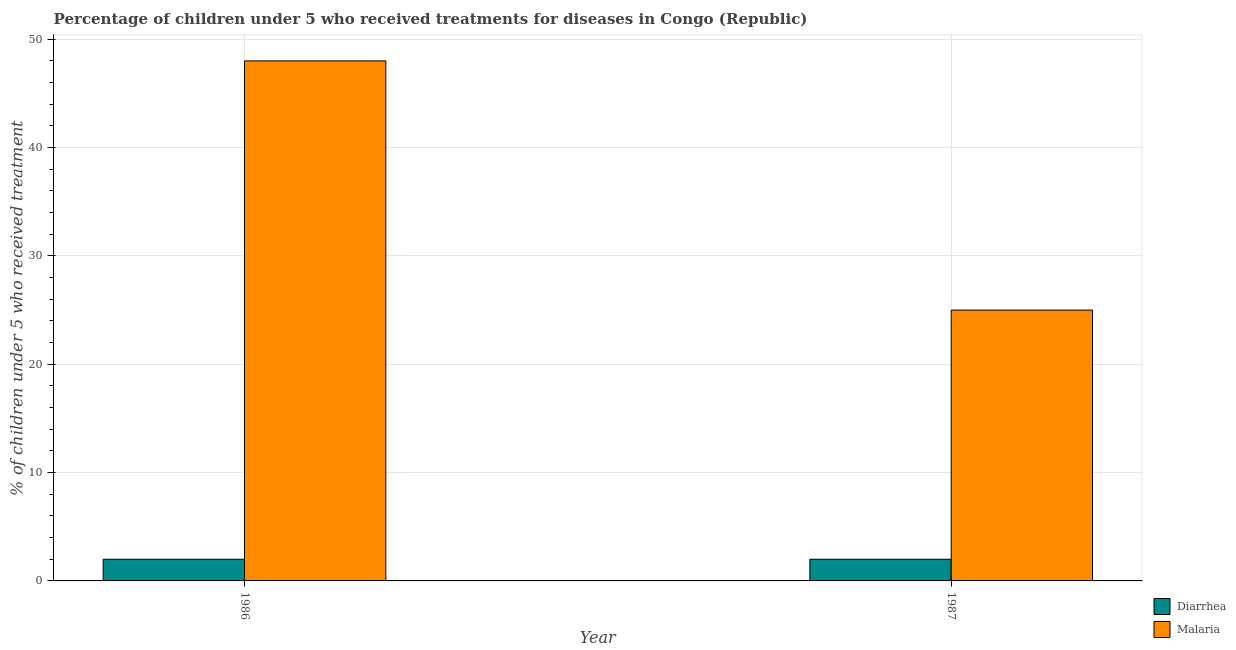How many different coloured bars are there?
Ensure brevity in your answer.  2. How many groups of bars are there?
Give a very brief answer. 2. Are the number of bars on each tick of the X-axis equal?
Give a very brief answer. Yes. How many bars are there on the 1st tick from the right?
Offer a terse response. 2. In how many cases, is the number of bars for a given year not equal to the number of legend labels?
Provide a succinct answer. 0. What is the percentage of children who received treatment for malaria in 1986?
Offer a very short reply. 48. Across all years, what is the maximum percentage of children who received treatment for malaria?
Your answer should be very brief. 48. Across all years, what is the minimum percentage of children who received treatment for malaria?
Your answer should be very brief. 25. In which year was the percentage of children who received treatment for diarrhoea maximum?
Ensure brevity in your answer.  1986. What is the total percentage of children who received treatment for diarrhoea in the graph?
Provide a succinct answer. 4. What is the difference between the percentage of children who received treatment for diarrhoea in 1986 and that in 1987?
Offer a terse response. 0. What is the difference between the percentage of children who received treatment for malaria in 1986 and the percentage of children who received treatment for diarrhoea in 1987?
Offer a terse response. 23. What is the ratio of the percentage of children who received treatment for malaria in 1986 to that in 1987?
Make the answer very short. 1.92. Is the percentage of children who received treatment for malaria in 1986 less than that in 1987?
Give a very brief answer. No. What does the 1st bar from the left in 1986 represents?
Offer a terse response. Diarrhea. What does the 2nd bar from the right in 1986 represents?
Your response must be concise. Diarrhea. How many bars are there?
Your response must be concise. 4. How many years are there in the graph?
Make the answer very short. 2. What is the difference between two consecutive major ticks on the Y-axis?
Your answer should be compact. 10. Are the values on the major ticks of Y-axis written in scientific E-notation?
Your answer should be compact. No. Does the graph contain any zero values?
Give a very brief answer. No. Where does the legend appear in the graph?
Your response must be concise. Bottom right. How are the legend labels stacked?
Your answer should be very brief. Vertical. What is the title of the graph?
Make the answer very short. Percentage of children under 5 who received treatments for diseases in Congo (Republic). Does "Commercial service imports" appear as one of the legend labels in the graph?
Your answer should be very brief. No. What is the label or title of the X-axis?
Ensure brevity in your answer.  Year. What is the label or title of the Y-axis?
Ensure brevity in your answer.  % of children under 5 who received treatment. What is the % of children under 5 who received treatment in Diarrhea in 1986?
Your response must be concise. 2. What is the % of children under 5 who received treatment of Malaria in 1986?
Your answer should be compact. 48. What is the % of children under 5 who received treatment in Malaria in 1987?
Make the answer very short. 25. Across all years, what is the maximum % of children under 5 who received treatment in Diarrhea?
Your answer should be very brief. 2. Across all years, what is the minimum % of children under 5 who received treatment in Diarrhea?
Your answer should be compact. 2. Across all years, what is the minimum % of children under 5 who received treatment in Malaria?
Give a very brief answer. 25. What is the total % of children under 5 who received treatment of Diarrhea in the graph?
Provide a succinct answer. 4. What is the total % of children under 5 who received treatment of Malaria in the graph?
Make the answer very short. 73. What is the difference between the % of children under 5 who received treatment of Malaria in 1986 and that in 1987?
Your answer should be very brief. 23. What is the average % of children under 5 who received treatment of Malaria per year?
Keep it short and to the point. 36.5. In the year 1986, what is the difference between the % of children under 5 who received treatment in Diarrhea and % of children under 5 who received treatment in Malaria?
Give a very brief answer. -46. In the year 1987, what is the difference between the % of children under 5 who received treatment in Diarrhea and % of children under 5 who received treatment in Malaria?
Your answer should be very brief. -23. What is the ratio of the % of children under 5 who received treatment in Malaria in 1986 to that in 1987?
Ensure brevity in your answer.  1.92. What is the difference between the highest and the second highest % of children under 5 who received treatment of Diarrhea?
Offer a terse response. 0. What is the difference between the highest and the second highest % of children under 5 who received treatment of Malaria?
Your response must be concise. 23. What is the difference between the highest and the lowest % of children under 5 who received treatment in Diarrhea?
Your response must be concise. 0. What is the difference between the highest and the lowest % of children under 5 who received treatment of Malaria?
Keep it short and to the point. 23. 